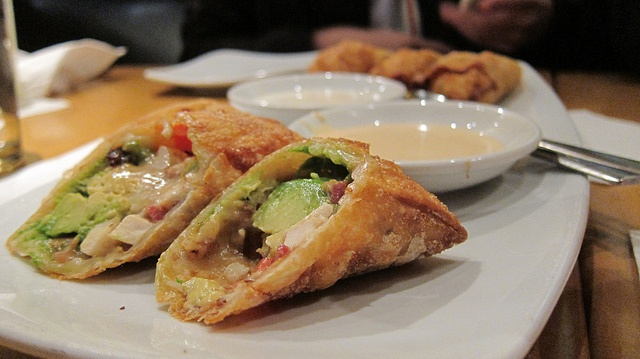Describe the objects in this image and their specific colors. I can see dining table in darkgray, black, tan, and brown tones, sandwich in black, tan, brown, and olive tones, sandwich in black, brown, tan, and maroon tones, people in black, maroon, and brown tones, and bowl in black, darkgray, tan, and gray tones in this image. 